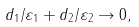Convert formula to latex. <formula><loc_0><loc_0><loc_500><loc_500>d _ { 1 } / \varepsilon _ { 1 } + d _ { 2 } / \varepsilon _ { 2 } \rightarrow 0 ,</formula> 